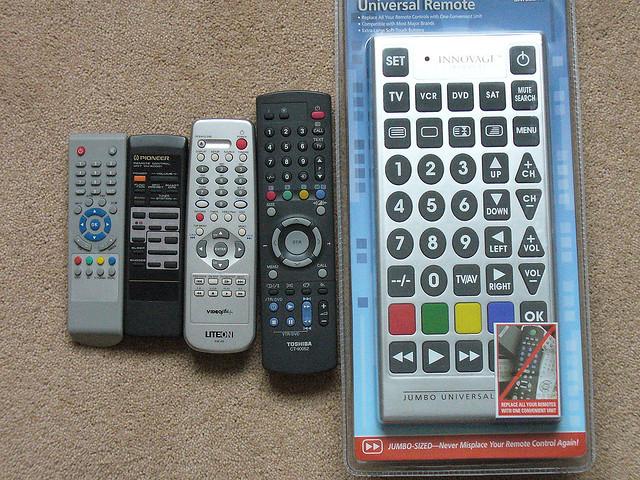How many devices are there?
Be succinct. 5. What shape are the numbered buttons on the largest remote?
Give a very brief answer. Circle. Which remote is the biggest?
Short answer required. Far right. What company is the silver remote from?
Quick response, please. Innovage. 